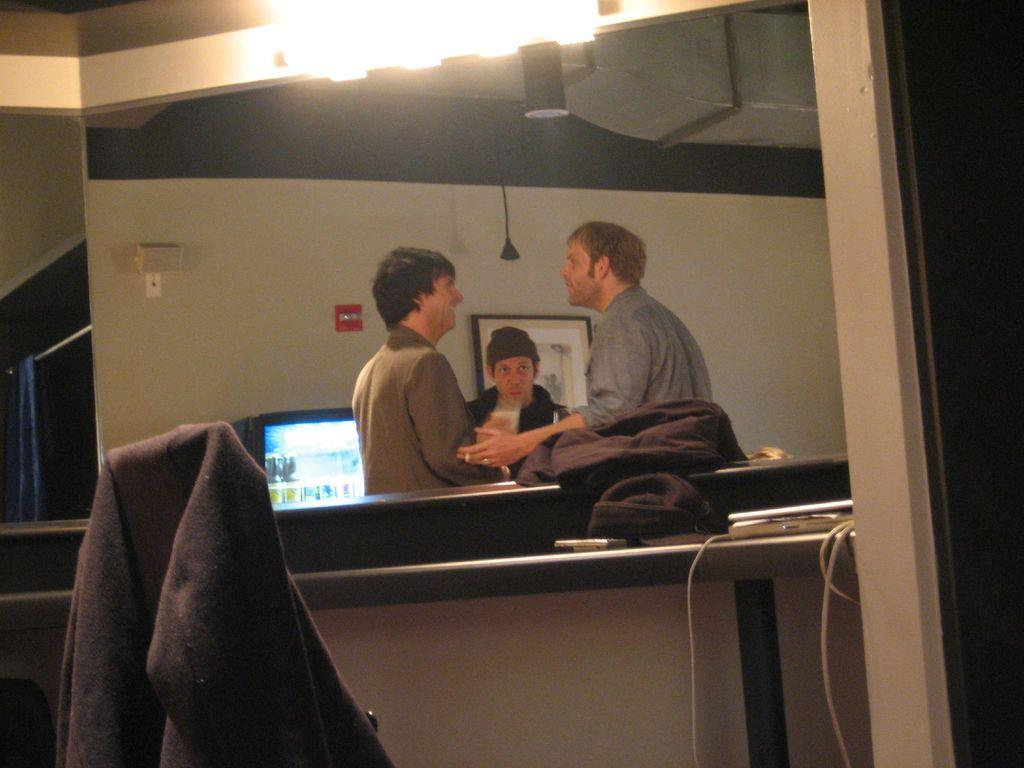How many people are in the image? There are three men in the image. What are the men doing in the image? The men are standing and discussing something. What can be seen at the top of the image? There are lights visible at the top of the image. What type of clothing is worn by the men in the image? The men are wearing aprons in the image. What type of tooth is being used by the men in the image? There are no teeth present in the image, and the men are not using any teeth for any activity. What type of hydrant is visible in the image? There is no hydrant present in the image. 